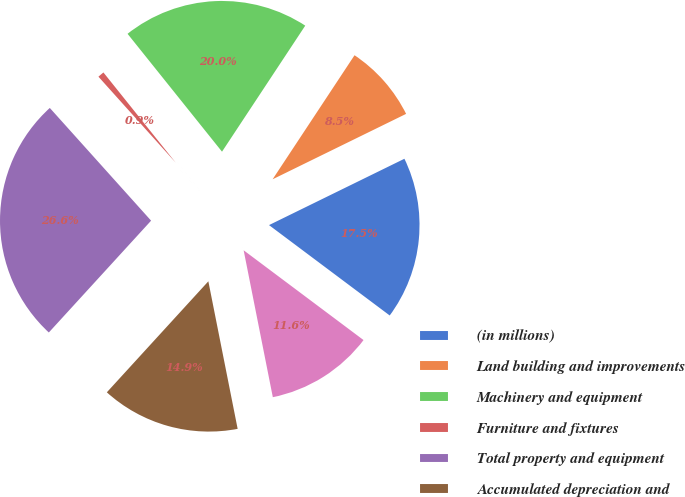Convert chart. <chart><loc_0><loc_0><loc_500><loc_500><pie_chart><fcel>(in millions)<fcel>Land building and improvements<fcel>Machinery and equipment<fcel>Furniture and fixtures<fcel>Total property and equipment<fcel>Accumulated depreciation and<fcel>Property and equipment net<nl><fcel>17.48%<fcel>8.46%<fcel>20.04%<fcel>0.9%<fcel>26.56%<fcel>14.91%<fcel>11.65%<nl></chart> 